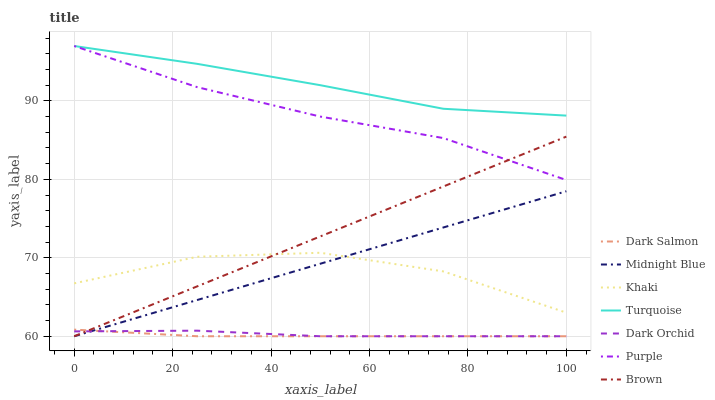Does Dark Salmon have the minimum area under the curve?
Answer yes or no. Yes. Does Turquoise have the maximum area under the curve?
Answer yes or no. Yes. Does Khaki have the minimum area under the curve?
Answer yes or no. No. Does Khaki have the maximum area under the curve?
Answer yes or no. No. Is Brown the smoothest?
Answer yes or no. Yes. Is Khaki the roughest?
Answer yes or no. Yes. Is Turquoise the smoothest?
Answer yes or no. No. Is Turquoise the roughest?
Answer yes or no. No. Does Brown have the lowest value?
Answer yes or no. Yes. Does Khaki have the lowest value?
Answer yes or no. No. Does Purple have the highest value?
Answer yes or no. Yes. Does Khaki have the highest value?
Answer yes or no. No. Is Dark Salmon less than Turquoise?
Answer yes or no. Yes. Is Khaki greater than Dark Salmon?
Answer yes or no. Yes. Does Dark Salmon intersect Brown?
Answer yes or no. Yes. Is Dark Salmon less than Brown?
Answer yes or no. No. Is Dark Salmon greater than Brown?
Answer yes or no. No. Does Dark Salmon intersect Turquoise?
Answer yes or no. No. 